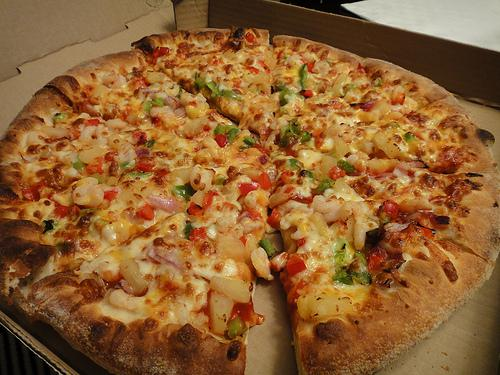Question: what is this?
Choices:
A. Hot dog.
B. Pizza.
C. Hamburger.
D. Lasagna.
Answer with the letter. Answer: B Question: what is in the photo?
Choices:
A. Cat.
B. Dog.
C. Pitcher of lemonade.
D. Food.
Answer with the letter. Answer: D Question: who is prsent?
Choices:
A. A man.
B. Nobody.
C. A woman.
D. A boy.
Answer with the letter. Answer: B Question: where is this scene?
Choices:
A. Up-close pizza.
B. Up-close sandwich.
C. Up-close pasta.
D. Up-close calzone.
Answer with the letter. Answer: A Question: why is there food?
Choices:
A. For show.
B. For giving.
C. For throwing away.
D. For eating.
Answer with the letter. Answer: D 